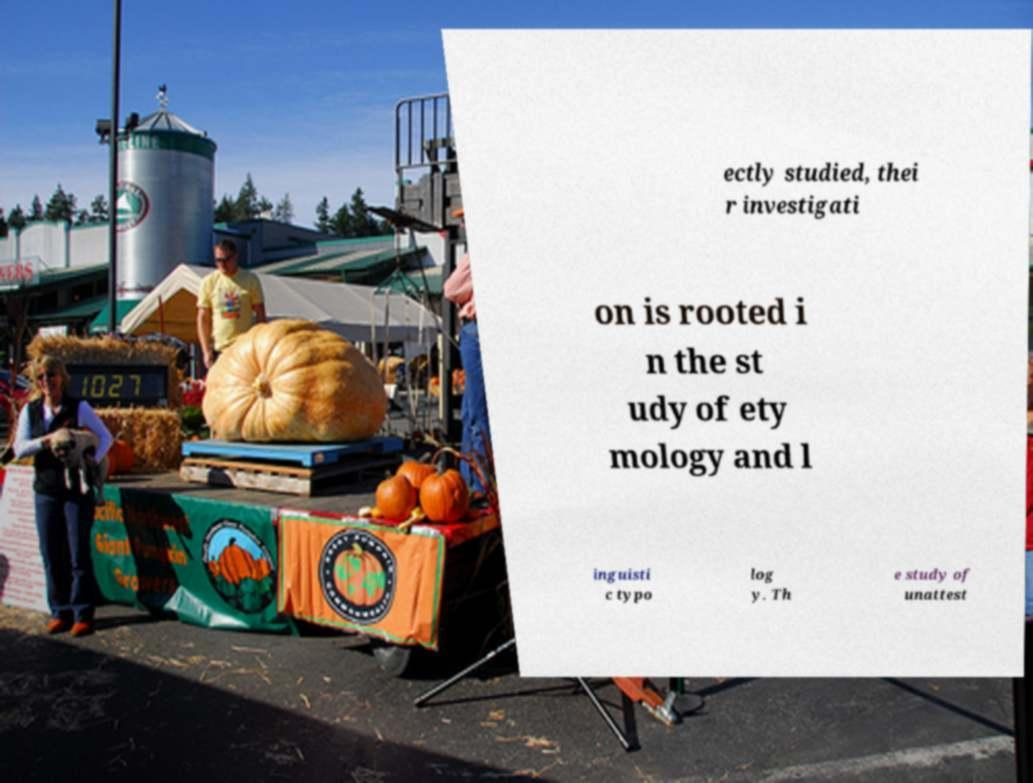Can you accurately transcribe the text from the provided image for me? ectly studied, thei r investigati on is rooted i n the st udy of ety mology and l inguisti c typo log y. Th e study of unattest 